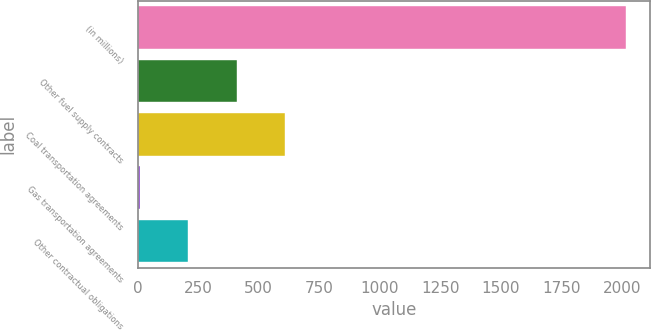<chart> <loc_0><loc_0><loc_500><loc_500><bar_chart><fcel>(in millions)<fcel>Other fuel supply contracts<fcel>Coal transportation agreements<fcel>Gas transportation agreements<fcel>Other contractual obligations<nl><fcel>2016<fcel>409.6<fcel>610.4<fcel>8<fcel>208.8<nl></chart> 